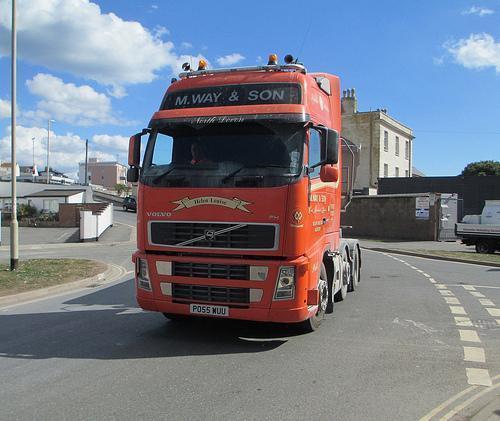How many people are in the truck?
Give a very brief answer. 1. 